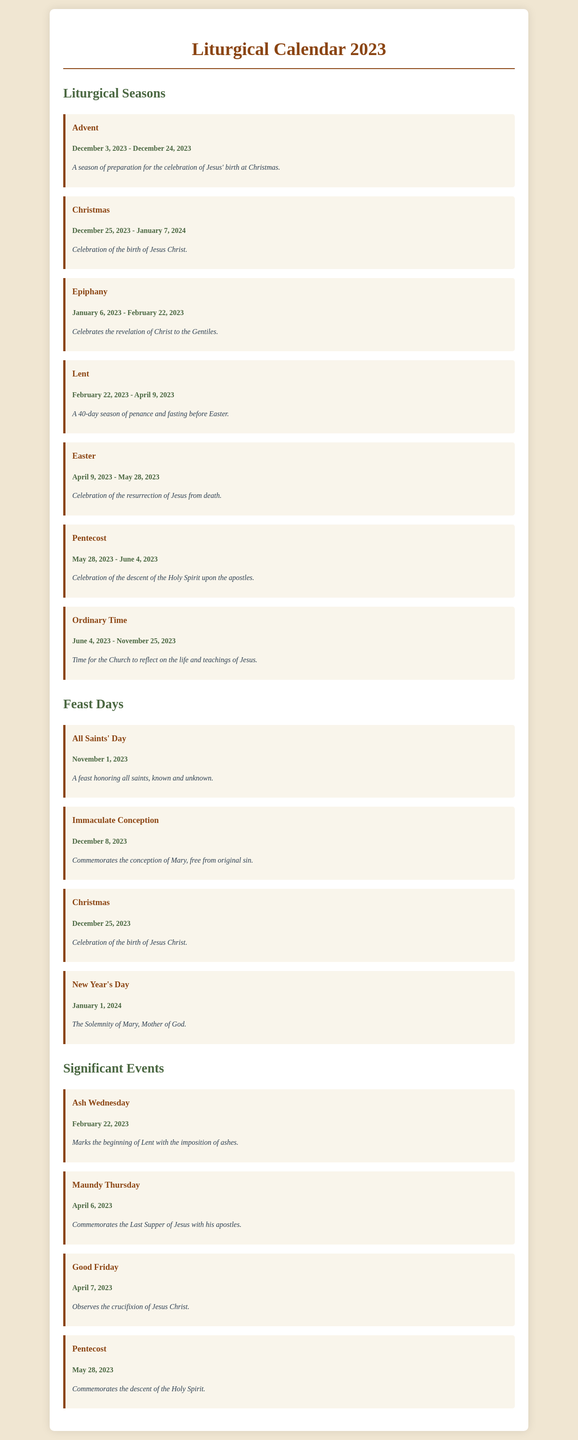What are the dates for Lent in 2023? Lent starts on February 22, 2023, and ends on April 9, 2023.
Answer: February 22, 2023 - April 9, 2023 What season follows Easter? After the Easter season, Ordinary Time begins, as indicated in the document.
Answer: Ordinary Time What date is All Saints' Day celebrated in 2023? All Saints' Day is mentioned as being celebrated on November 1, 2023.
Answer: November 1, 2023 What is the last day of Epiphany in 2023? The document states that Epiphany ends on February 22, 2023.
Answer: February 22, 2023 What significant event marks the beginning of Lent? The imposition of ashes on Ash Wednesday is the event that begins Lent.
Answer: Ash Wednesday How long does the Christmas season last in 2023? Christmas lasts from December 25, 2023, to January 7, 2024, according to the document.
Answer: 14 days What feast commemorates the conception of Mary? The Immaculate Conception commemorates Mary's conception.
Answer: Immaculate Conception When does Pentecost occur in 2023? Pentecost is celebrated on May 28, 2023, as specified in the document.
Answer: May 28, 2023 